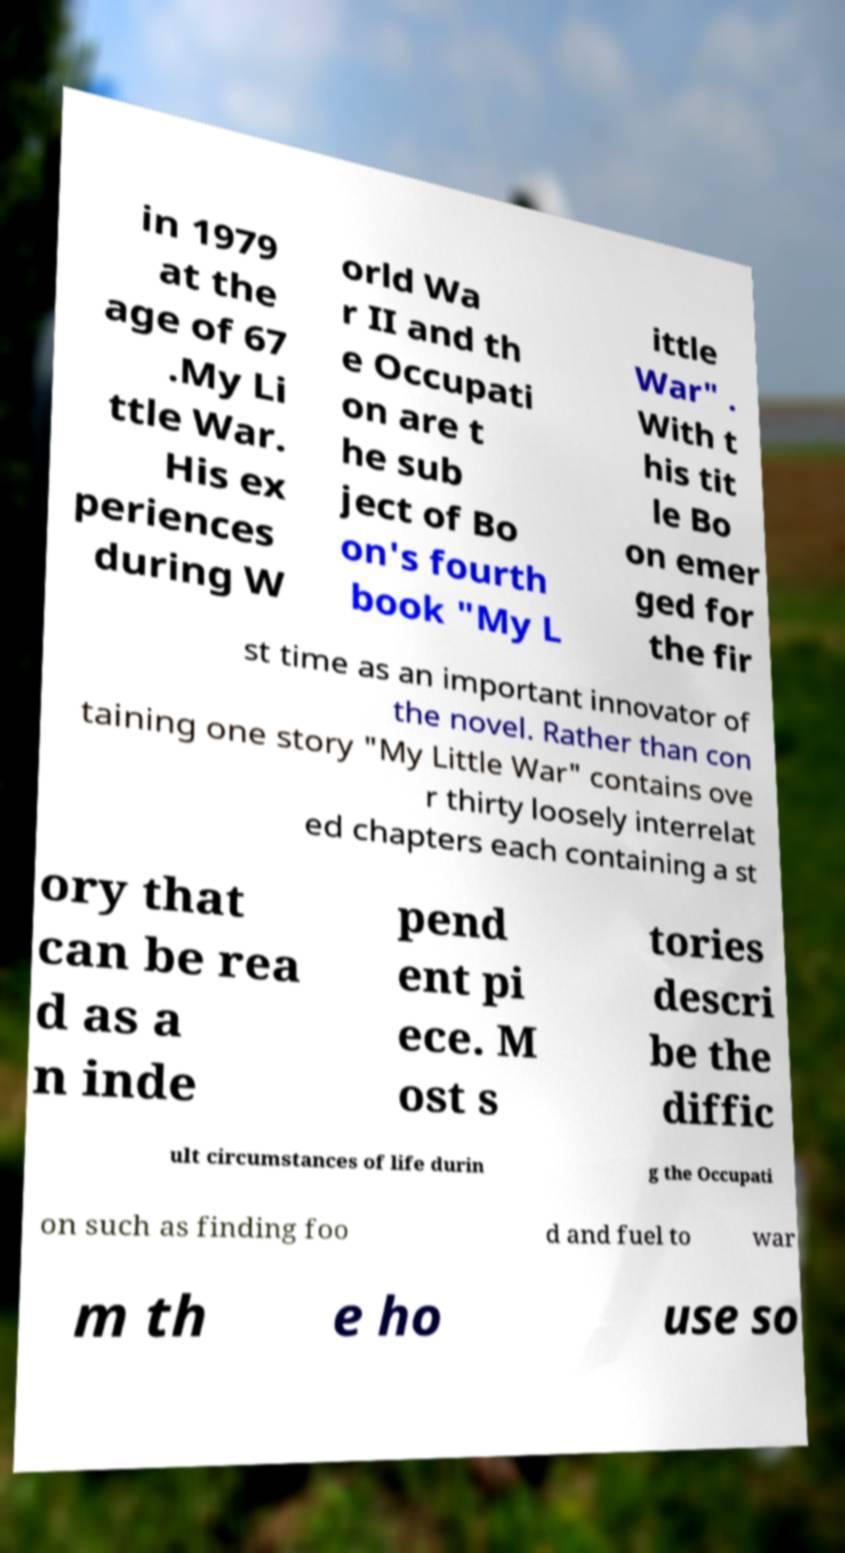I need the written content from this picture converted into text. Can you do that? in 1979 at the age of 67 .My Li ttle War. His ex periences during W orld Wa r II and th e Occupati on are t he sub ject of Bo on's fourth book "My L ittle War" . With t his tit le Bo on emer ged for the fir st time as an important innovator of the novel. Rather than con taining one story "My Little War" contains ove r thirty loosely interrelat ed chapters each containing a st ory that can be rea d as a n inde pend ent pi ece. M ost s tories descri be the diffic ult circumstances of life durin g the Occupati on such as finding foo d and fuel to war m th e ho use so 